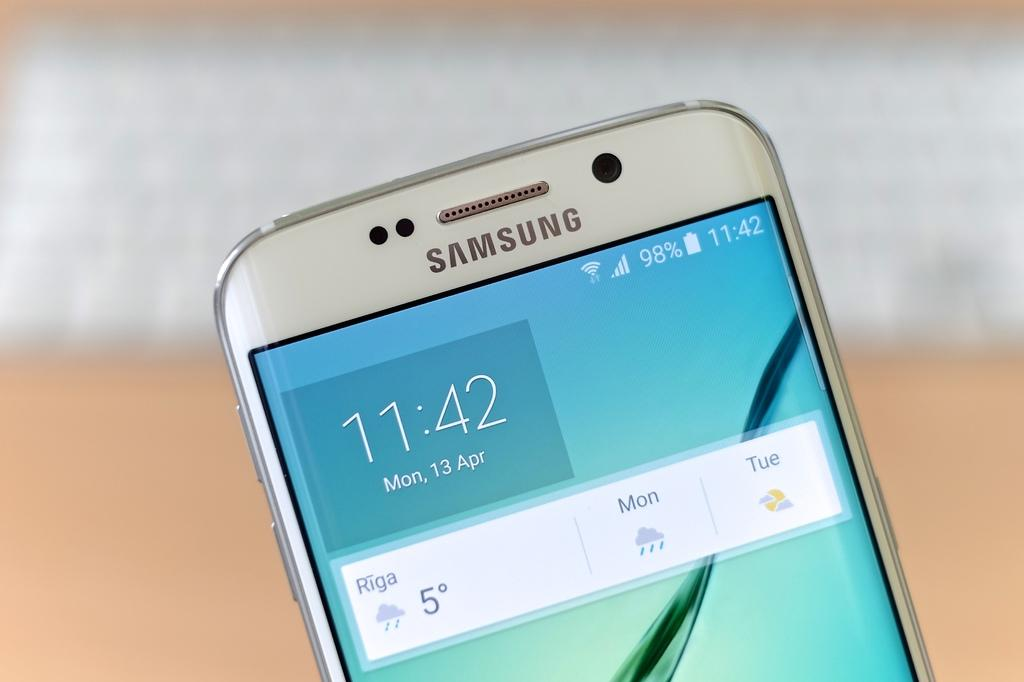Provide a one-sentence caption for the provided image. A Samsung cell phone displaying the time as 11:42. 